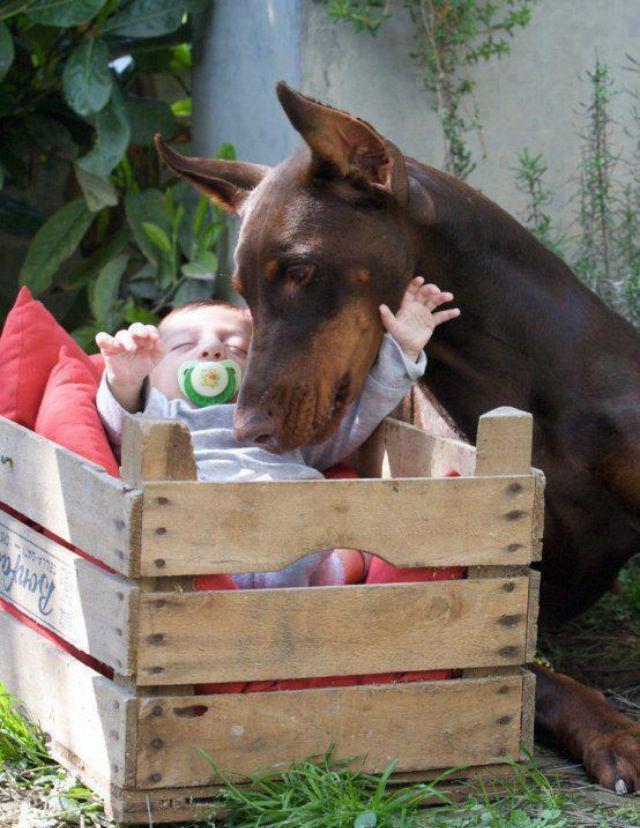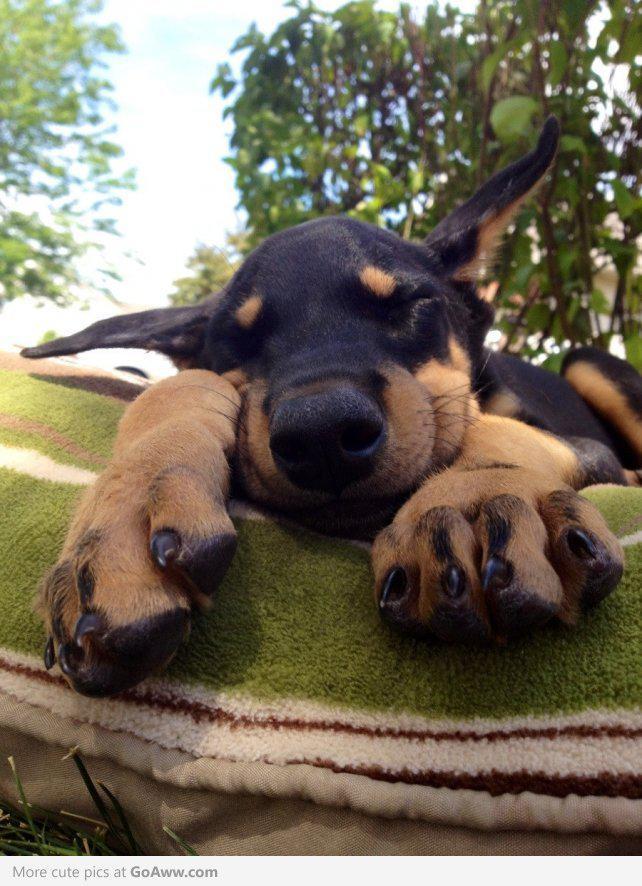The first image is the image on the left, the second image is the image on the right. Considering the images on both sides, is "there are two dogs on the grass, one of the dogs is laying down" valid? Answer yes or no. No. The first image is the image on the left, the second image is the image on the right. For the images displayed, is the sentence "There are three dogs and one is a puppy." factually correct? Answer yes or no. No. 